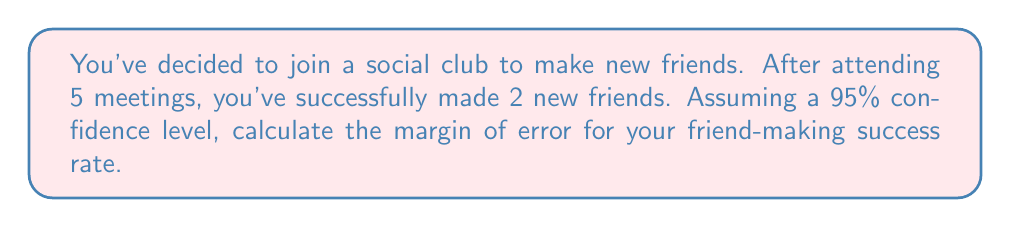Can you answer this question? Let's approach this step-by-step:

1) First, we need to calculate the sample proportion (p):
   $p = \frac{\text{number of successes}}{\text{total attempts}} = \frac{2}{5} = 0.4$

2) The formula for margin of error is:
   $\text{Margin of Error} = z^* \sqrt{\frac{p(1-p)}{n}}$

   Where:
   - $z^*$ is the critical value (for 95% confidence level, $z^* = 1.96$)
   - $p$ is the sample proportion
   - $n$ is the sample size

3) Let's plug in our values:
   $\text{Margin of Error} = 1.96 \sqrt{\frac{0.4(1-0.4)}{5}}$

4) Simplify inside the square root:
   $\text{Margin of Error} = 1.96 \sqrt{\frac{0.4(0.6)}{5}} = 1.96 \sqrt{\frac{0.24}{5}}$

5) Calculate:
   $\text{Margin of Error} = 1.96 \sqrt{0.048} \approx 1.96 * 0.219 \approx 0.429$

6) Convert to percentage:
   $0.429 * 100\% = 42.9\%$

Therefore, the margin of error for your friend-making success rate is approximately 42.9%.
Answer: 42.9% 